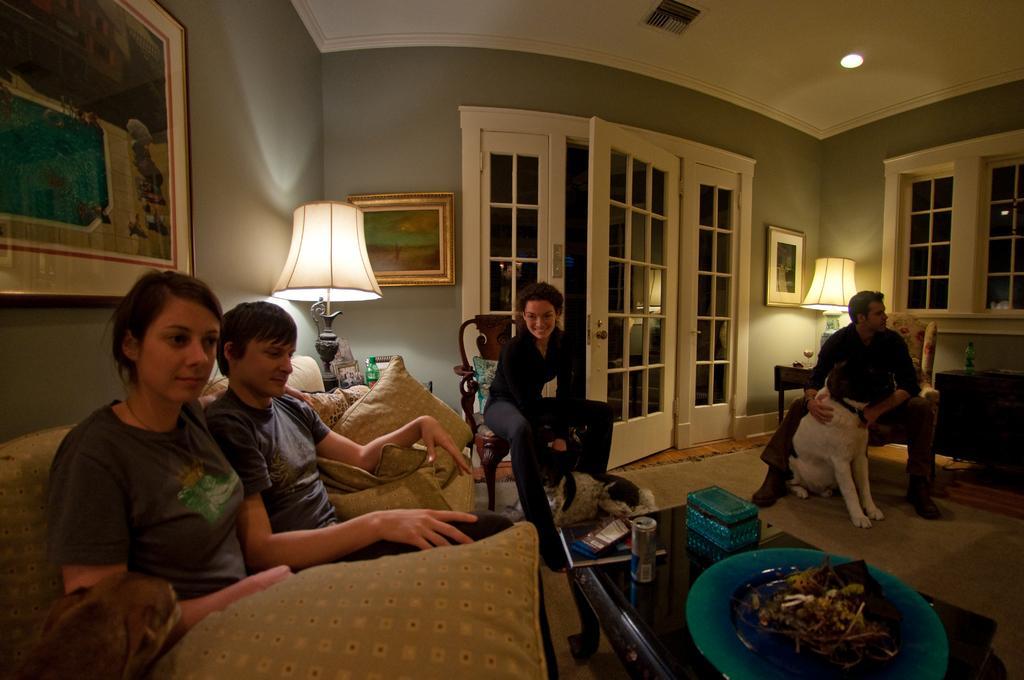Describe this image in one or two sentences. In the given image we can see that, there are four persons inside a room. Two of them are sitting on sofa and two of them are sitting on chair. This is a light lamp, there are photos stick to the wall. This is a door made up of glass. There is a table on the table there is can and a plate. 